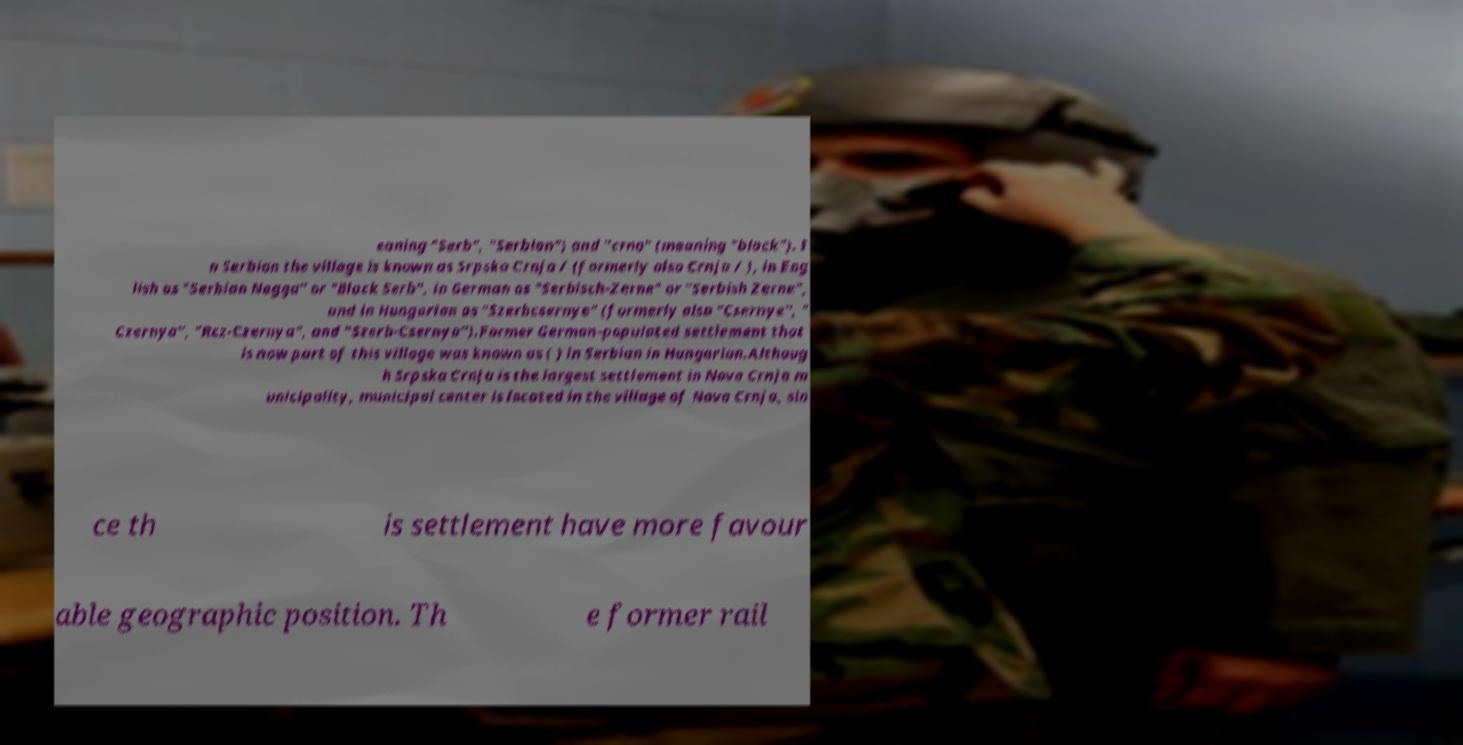What messages or text are displayed in this image? I need them in a readable, typed format. eaning "Serb", "Serbian") and "crno" (meaning "black"). I n Serbian the village is known as Srpska Crnja / (formerly also Crnja / ), in Eng lish as "Serbian Negga" or "Black Serb", in German as "Serbisch-Zerne" or "Serbish Zerne", and in Hungarian as "Szerbcsernye" (formerly also "Csernye", " Czernya", "Rcz-Czernya", and "Szerb-Csernya").Former German-populated settlement that is now part of this village was known as ( ) in Serbian in Hungarian.Althoug h Srpska Crnja is the largest settlement in Nova Crnja m unicipality, municipal center is located in the village of Nova Crnja, sin ce th is settlement have more favour able geographic position. Th e former rail 